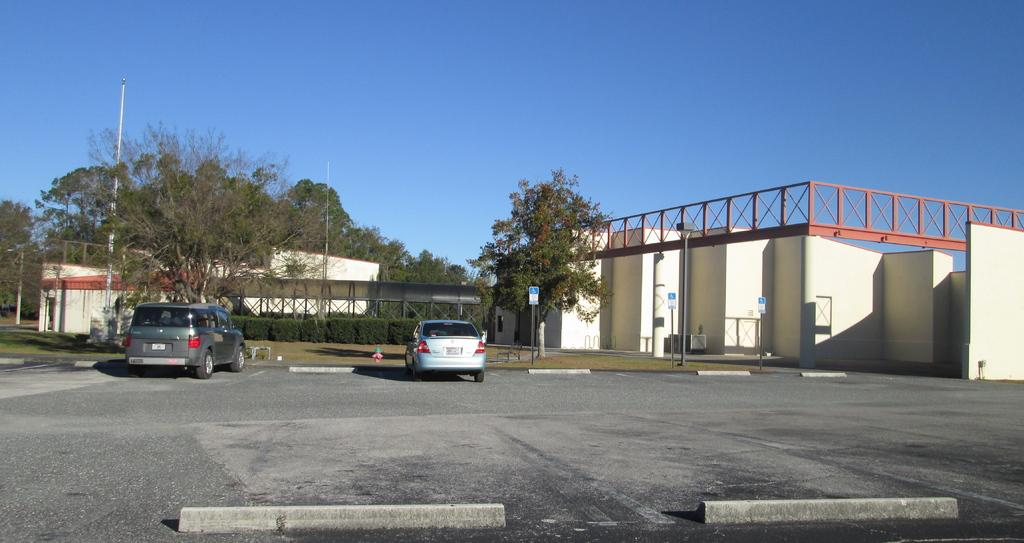How many cars are on the road in the image? There are two cars on the road in the image. What type of vegetation can be seen in the image? There is grass, plants, and trees in the image. What structures are present in the image? There are poles, boards, and houses in the image. What is visible in the background of the image? The sky is visible in the background of the image. Can you see any matches being used for writing in the image? There are no matches or writing present in the image. What type of powder is visible on the trees in the image? There is no powder visible on the trees in the image. 